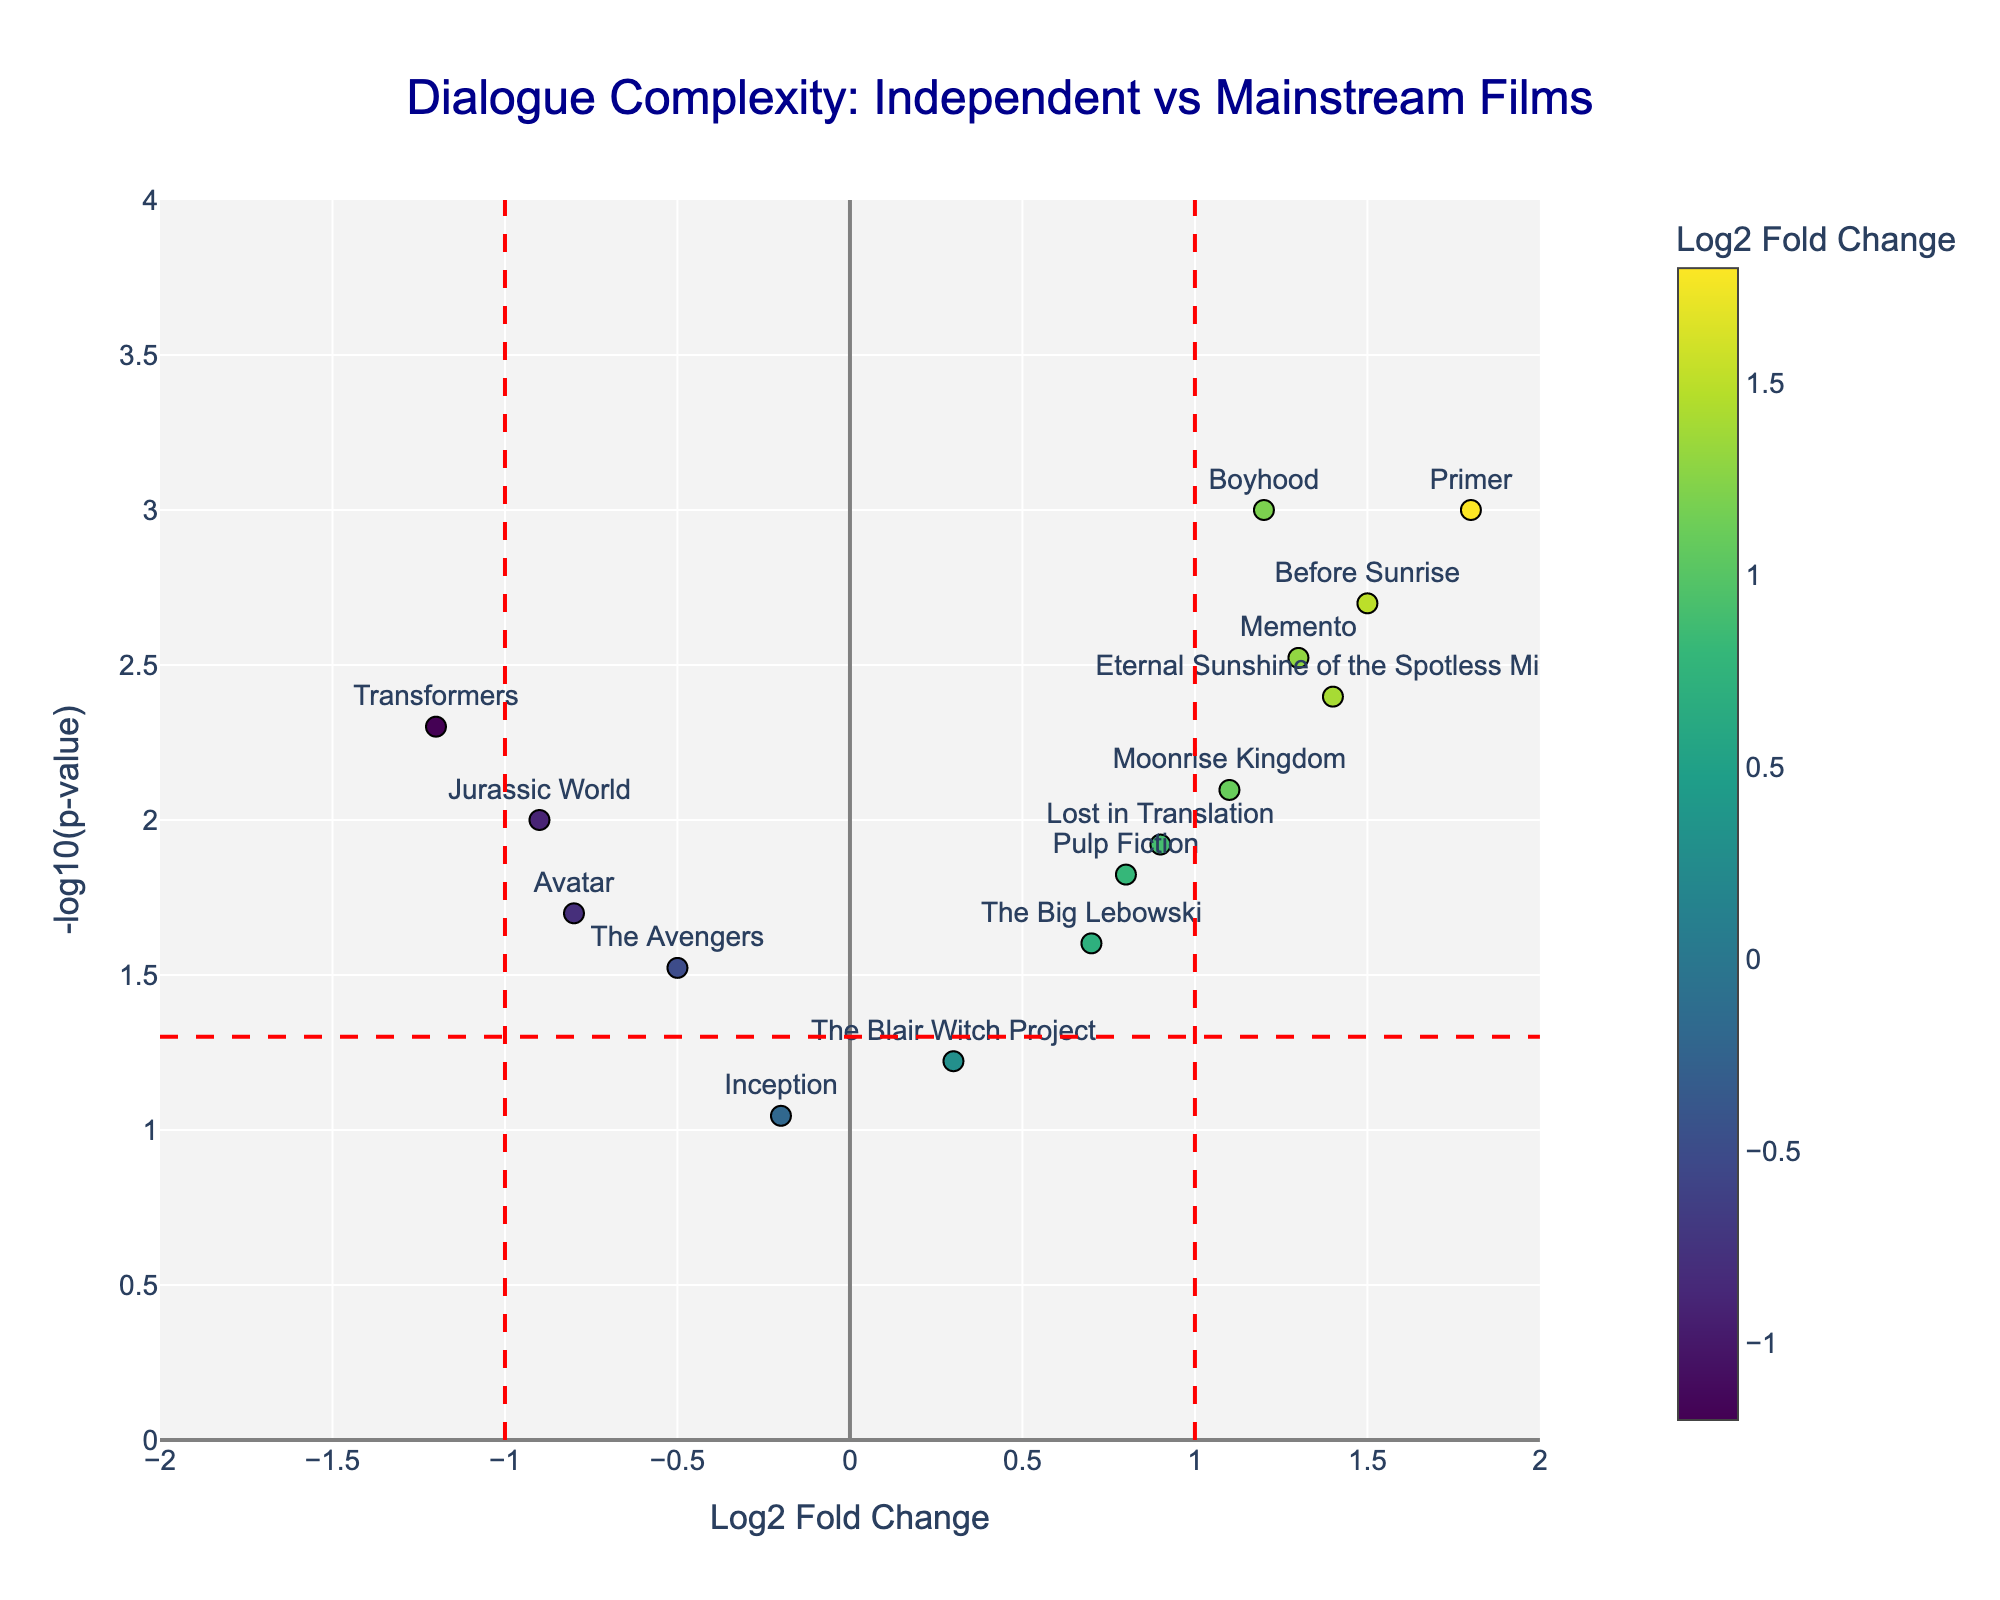What is the title of the volcano plot? The title is displayed at the top center of the figure. It should provide an overview of what the plot represents.
Answer: Dialogue Complexity: Independent vs Mainstream Films What does the x-axis represent in the plot? The x-axis label is located at the bottom of the figure. It indicates the variable plotted horizontally.
Answer: Log2 Fold Change Which film has the highest -log10(p-value)? The highest -log10(p-value) corresponds to the highest y-coordinate. By looking at the plot, we can identify which film is positioned at the highest point on the y-axis.
Answer: Primer What color scale is used to represent the Log2 Fold Change? The color scale can be identified by looking at the color bar on the right side of the plot. It shows a gradient and the title.
Answer: Viridis Which independent film shows the highest dialogue complexity based on Log2 Fold Change? Dialogue complexity for independent films is represented by their position along the x-axis. The highest positive Log2 Fold Change indicates the highest complexity. By examining the plot, we can identify this film from the positive side.
Answer: Primer What is the p-value threshold indicated by a horizontal red dashed line? The threshold can be identified by the height at which the horizontal red dashed line is drawn. The y-coordinate where this line is placed corresponds to the threshold.
Answer: 0.05 How many mainstream films have a Log2 Fold Change lower than -1? Look for data points located to the left of the vertical red dashed line at -1 on the x-axis. Count these data points.
Answer: Three (Transformers, Avatar, Jurassic World) Which films fall within the non-significant p-value range (above the red horizontal line)? Films above the red horizontal line have non-significant p-values. Identify the films based on their position relative to this line.
Answer: The Blair Witch Project, Inception Compare the dialogue complexity of "Boyhood" and "The Avengers." Which one has a higher Log2 Fold Change? Find the positions of both films on the x-axis. Boyhood and The Avengers' x-coordinates will tell you their Log2 Fold Changes, and you can see which one is greater.
Answer: Boyhood Which film has the smallest p-value, and does it belong to an independent or mainstream film? The smallest p-value corresponds to the highest point on the y-axis. Identify the film and check if it is listed commonly as an independent or mainstream film.
Answer: Primer, Independent 